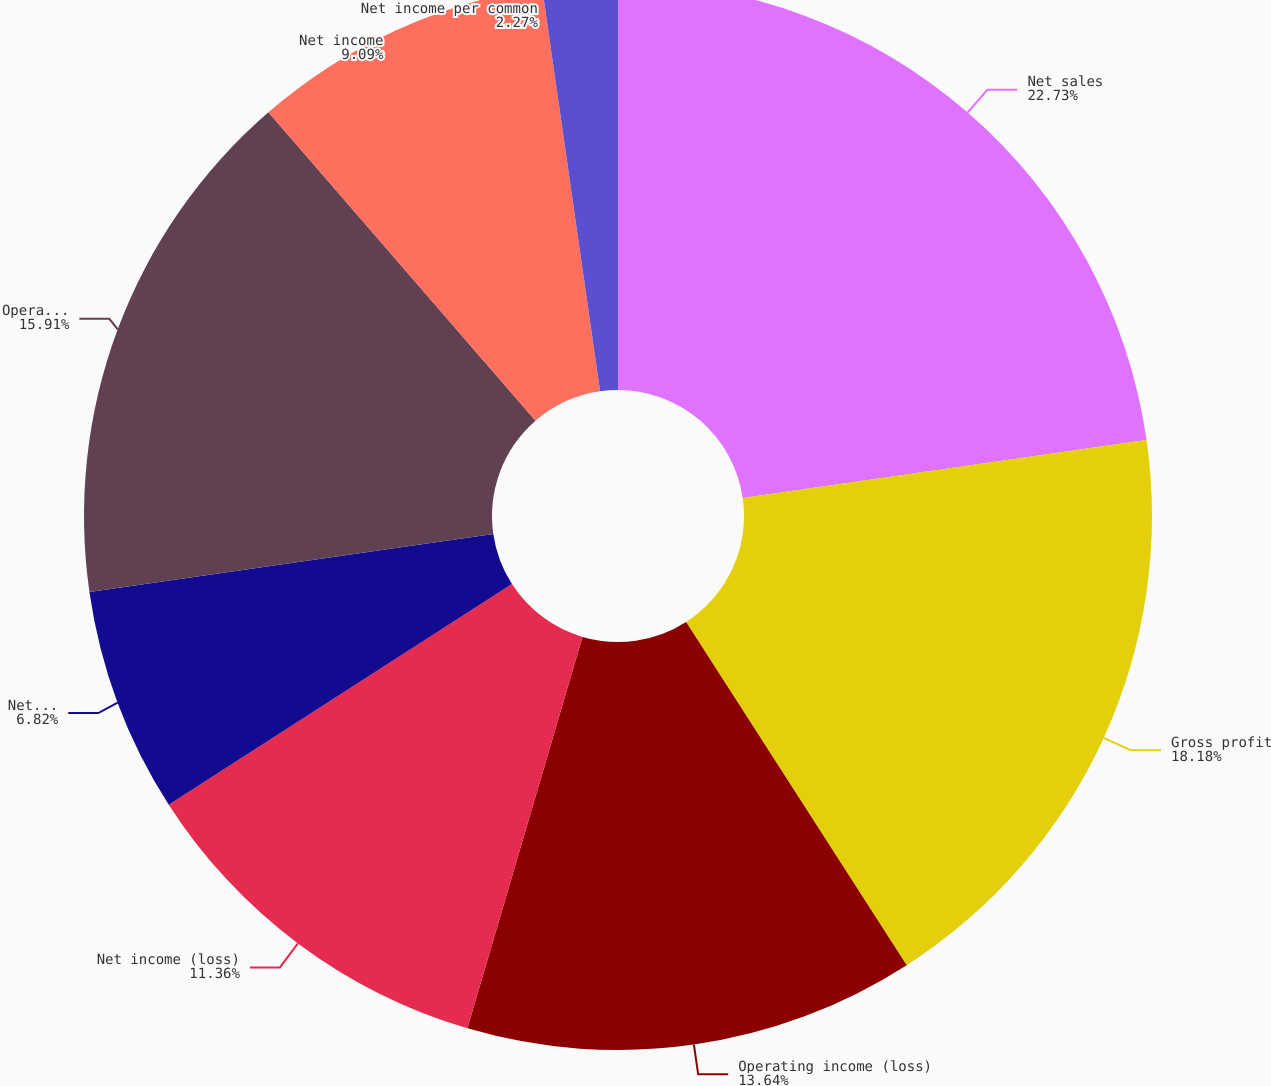<chart> <loc_0><loc_0><loc_500><loc_500><pie_chart><fcel>Net sales<fcel>Gross profit<fcel>Operating income (loss)<fcel>Net income (loss)<fcel>Net income (loss) per common<fcel>Operating income<fcel>Net income<fcel>Net income per common<nl><fcel>22.73%<fcel>18.18%<fcel>13.64%<fcel>11.36%<fcel>6.82%<fcel>15.91%<fcel>9.09%<fcel>2.27%<nl></chart> 